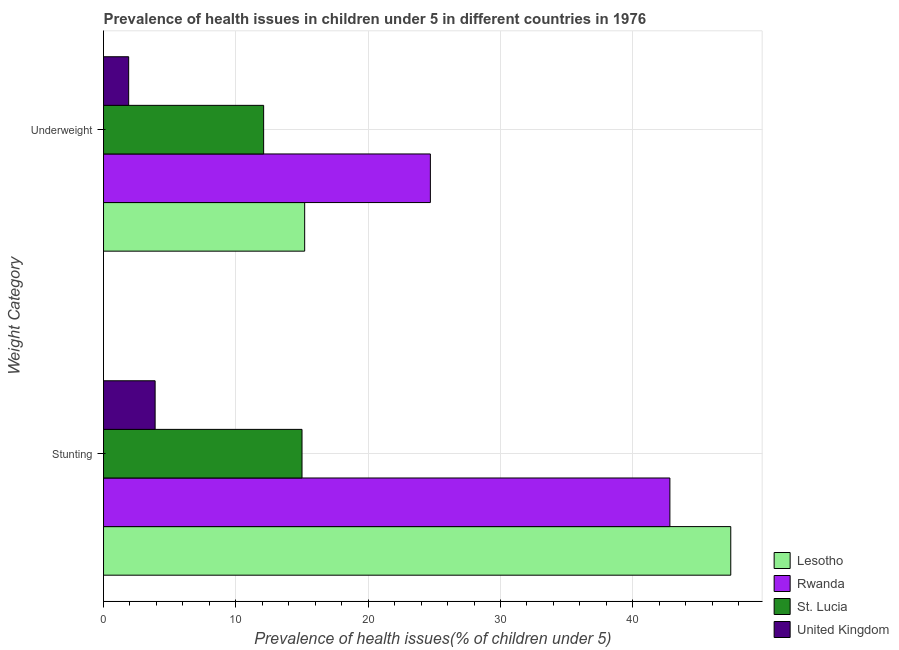How many groups of bars are there?
Offer a terse response. 2. Are the number of bars per tick equal to the number of legend labels?
Your response must be concise. Yes. Are the number of bars on each tick of the Y-axis equal?
Your response must be concise. Yes. How many bars are there on the 1st tick from the top?
Give a very brief answer. 4. What is the label of the 2nd group of bars from the top?
Offer a very short reply. Stunting. What is the percentage of underweight children in Lesotho?
Your response must be concise. 15.2. Across all countries, what is the maximum percentage of stunted children?
Offer a very short reply. 47.4. Across all countries, what is the minimum percentage of stunted children?
Your answer should be very brief. 3.9. In which country was the percentage of underweight children maximum?
Provide a short and direct response. Rwanda. In which country was the percentage of stunted children minimum?
Keep it short and to the point. United Kingdom. What is the total percentage of underweight children in the graph?
Give a very brief answer. 53.9. What is the difference between the percentage of stunted children in United Kingdom and that in Rwanda?
Ensure brevity in your answer.  -38.9. What is the difference between the percentage of stunted children in Lesotho and the percentage of underweight children in St. Lucia?
Your response must be concise. 35.3. What is the average percentage of underweight children per country?
Keep it short and to the point. 13.48. What is the difference between the percentage of stunted children and percentage of underweight children in Lesotho?
Give a very brief answer. 32.2. In how many countries, is the percentage of stunted children greater than 10 %?
Offer a terse response. 3. What is the ratio of the percentage of stunted children in St. Lucia to that in Rwanda?
Your answer should be very brief. 0.35. Is the percentage of stunted children in United Kingdom less than that in Lesotho?
Your answer should be compact. Yes. In how many countries, is the percentage of stunted children greater than the average percentage of stunted children taken over all countries?
Your answer should be very brief. 2. What does the 1st bar from the top in Stunting represents?
Offer a terse response. United Kingdom. What does the 2nd bar from the bottom in Underweight represents?
Provide a succinct answer. Rwanda. How many bars are there?
Provide a succinct answer. 8. Are all the bars in the graph horizontal?
Your response must be concise. Yes. What is the difference between two consecutive major ticks on the X-axis?
Give a very brief answer. 10. Are the values on the major ticks of X-axis written in scientific E-notation?
Ensure brevity in your answer.  No. Does the graph contain any zero values?
Provide a succinct answer. No. Does the graph contain grids?
Make the answer very short. Yes. Where does the legend appear in the graph?
Give a very brief answer. Bottom right. How are the legend labels stacked?
Your response must be concise. Vertical. What is the title of the graph?
Give a very brief answer. Prevalence of health issues in children under 5 in different countries in 1976. Does "High income" appear as one of the legend labels in the graph?
Give a very brief answer. No. What is the label or title of the X-axis?
Provide a short and direct response. Prevalence of health issues(% of children under 5). What is the label or title of the Y-axis?
Ensure brevity in your answer.  Weight Category. What is the Prevalence of health issues(% of children under 5) in Lesotho in Stunting?
Provide a short and direct response. 47.4. What is the Prevalence of health issues(% of children under 5) of Rwanda in Stunting?
Offer a very short reply. 42.8. What is the Prevalence of health issues(% of children under 5) in United Kingdom in Stunting?
Keep it short and to the point. 3.9. What is the Prevalence of health issues(% of children under 5) in Lesotho in Underweight?
Provide a succinct answer. 15.2. What is the Prevalence of health issues(% of children under 5) in Rwanda in Underweight?
Make the answer very short. 24.7. What is the Prevalence of health issues(% of children under 5) of St. Lucia in Underweight?
Provide a succinct answer. 12.1. What is the Prevalence of health issues(% of children under 5) of United Kingdom in Underweight?
Your answer should be very brief. 1.9. Across all Weight Category, what is the maximum Prevalence of health issues(% of children under 5) of Lesotho?
Offer a terse response. 47.4. Across all Weight Category, what is the maximum Prevalence of health issues(% of children under 5) of Rwanda?
Keep it short and to the point. 42.8. Across all Weight Category, what is the maximum Prevalence of health issues(% of children under 5) in United Kingdom?
Provide a short and direct response. 3.9. Across all Weight Category, what is the minimum Prevalence of health issues(% of children under 5) in Lesotho?
Provide a short and direct response. 15.2. Across all Weight Category, what is the minimum Prevalence of health issues(% of children under 5) in Rwanda?
Make the answer very short. 24.7. Across all Weight Category, what is the minimum Prevalence of health issues(% of children under 5) of St. Lucia?
Provide a succinct answer. 12.1. Across all Weight Category, what is the minimum Prevalence of health issues(% of children under 5) of United Kingdom?
Your answer should be very brief. 1.9. What is the total Prevalence of health issues(% of children under 5) in Lesotho in the graph?
Your answer should be very brief. 62.6. What is the total Prevalence of health issues(% of children under 5) in Rwanda in the graph?
Offer a terse response. 67.5. What is the total Prevalence of health issues(% of children under 5) of St. Lucia in the graph?
Ensure brevity in your answer.  27.1. What is the total Prevalence of health issues(% of children under 5) in United Kingdom in the graph?
Provide a short and direct response. 5.8. What is the difference between the Prevalence of health issues(% of children under 5) in Lesotho in Stunting and that in Underweight?
Your response must be concise. 32.2. What is the difference between the Prevalence of health issues(% of children under 5) of St. Lucia in Stunting and that in Underweight?
Keep it short and to the point. 2.9. What is the difference between the Prevalence of health issues(% of children under 5) in United Kingdom in Stunting and that in Underweight?
Ensure brevity in your answer.  2. What is the difference between the Prevalence of health issues(% of children under 5) of Lesotho in Stunting and the Prevalence of health issues(% of children under 5) of Rwanda in Underweight?
Offer a terse response. 22.7. What is the difference between the Prevalence of health issues(% of children under 5) in Lesotho in Stunting and the Prevalence of health issues(% of children under 5) in St. Lucia in Underweight?
Your answer should be compact. 35.3. What is the difference between the Prevalence of health issues(% of children under 5) of Lesotho in Stunting and the Prevalence of health issues(% of children under 5) of United Kingdom in Underweight?
Offer a terse response. 45.5. What is the difference between the Prevalence of health issues(% of children under 5) in Rwanda in Stunting and the Prevalence of health issues(% of children under 5) in St. Lucia in Underweight?
Offer a terse response. 30.7. What is the difference between the Prevalence of health issues(% of children under 5) in Rwanda in Stunting and the Prevalence of health issues(% of children under 5) in United Kingdom in Underweight?
Your response must be concise. 40.9. What is the average Prevalence of health issues(% of children under 5) of Lesotho per Weight Category?
Offer a very short reply. 31.3. What is the average Prevalence of health issues(% of children under 5) in Rwanda per Weight Category?
Keep it short and to the point. 33.75. What is the average Prevalence of health issues(% of children under 5) in St. Lucia per Weight Category?
Keep it short and to the point. 13.55. What is the average Prevalence of health issues(% of children under 5) of United Kingdom per Weight Category?
Ensure brevity in your answer.  2.9. What is the difference between the Prevalence of health issues(% of children under 5) of Lesotho and Prevalence of health issues(% of children under 5) of St. Lucia in Stunting?
Provide a succinct answer. 32.4. What is the difference between the Prevalence of health issues(% of children under 5) of Lesotho and Prevalence of health issues(% of children under 5) of United Kingdom in Stunting?
Your response must be concise. 43.5. What is the difference between the Prevalence of health issues(% of children under 5) of Rwanda and Prevalence of health issues(% of children under 5) of St. Lucia in Stunting?
Ensure brevity in your answer.  27.8. What is the difference between the Prevalence of health issues(% of children under 5) of Rwanda and Prevalence of health issues(% of children under 5) of United Kingdom in Stunting?
Your answer should be compact. 38.9. What is the difference between the Prevalence of health issues(% of children under 5) of St. Lucia and Prevalence of health issues(% of children under 5) of United Kingdom in Stunting?
Your response must be concise. 11.1. What is the difference between the Prevalence of health issues(% of children under 5) of Lesotho and Prevalence of health issues(% of children under 5) of St. Lucia in Underweight?
Provide a succinct answer. 3.1. What is the difference between the Prevalence of health issues(% of children under 5) of Lesotho and Prevalence of health issues(% of children under 5) of United Kingdom in Underweight?
Your answer should be compact. 13.3. What is the difference between the Prevalence of health issues(% of children under 5) of Rwanda and Prevalence of health issues(% of children under 5) of St. Lucia in Underweight?
Offer a very short reply. 12.6. What is the difference between the Prevalence of health issues(% of children under 5) in Rwanda and Prevalence of health issues(% of children under 5) in United Kingdom in Underweight?
Ensure brevity in your answer.  22.8. What is the difference between the Prevalence of health issues(% of children under 5) of St. Lucia and Prevalence of health issues(% of children under 5) of United Kingdom in Underweight?
Provide a succinct answer. 10.2. What is the ratio of the Prevalence of health issues(% of children under 5) of Lesotho in Stunting to that in Underweight?
Provide a succinct answer. 3.12. What is the ratio of the Prevalence of health issues(% of children under 5) of Rwanda in Stunting to that in Underweight?
Make the answer very short. 1.73. What is the ratio of the Prevalence of health issues(% of children under 5) of St. Lucia in Stunting to that in Underweight?
Give a very brief answer. 1.24. What is the ratio of the Prevalence of health issues(% of children under 5) in United Kingdom in Stunting to that in Underweight?
Provide a succinct answer. 2.05. What is the difference between the highest and the second highest Prevalence of health issues(% of children under 5) in Lesotho?
Give a very brief answer. 32.2. What is the difference between the highest and the second highest Prevalence of health issues(% of children under 5) in Rwanda?
Offer a very short reply. 18.1. What is the difference between the highest and the lowest Prevalence of health issues(% of children under 5) in Lesotho?
Give a very brief answer. 32.2. What is the difference between the highest and the lowest Prevalence of health issues(% of children under 5) of Rwanda?
Make the answer very short. 18.1. What is the difference between the highest and the lowest Prevalence of health issues(% of children under 5) of United Kingdom?
Give a very brief answer. 2. 